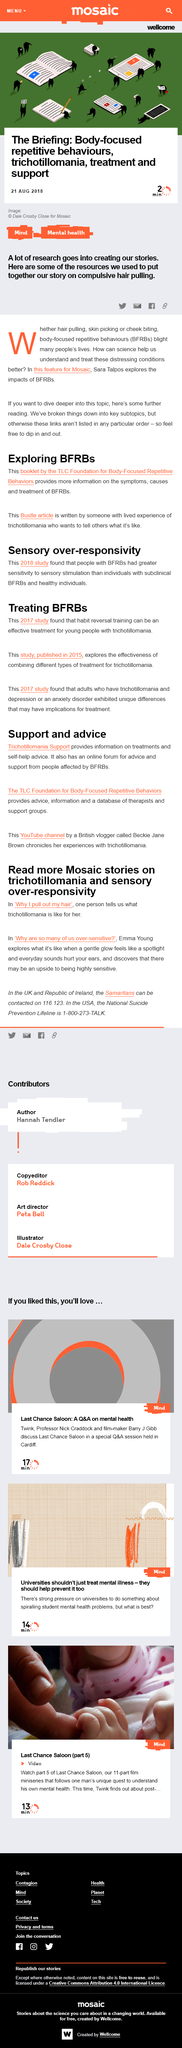Identify some key points in this picture. All studies involve trichotillomania, and trichotillomania is a condition characterized by repetitive hair-pulling from the scalp, eyebrows, or other areas of the body. This condition can lead to hair loss and scarring, and it is often associated with anxiety, depression, and other mental health conditions. While there are some effective treatments available for trichotillomania, it can be difficult to overcome without the right support and resources. Compulsive hair pulling, also known as trichotillomania, is a body-focused repetitive behavior characterized by the repetitive and compulsive urge to pull out one's hair, often resulting in hair loss. The date of the article is August 21, 2018. Reversal training, which was mentioned in a 2017 study, is a method of training in which learners are first taught about a negative outcome or mistake, followed by a later correction to produce a desired outcome. Beckie Jane Brown, a British vlogger, chronicles her experiences with trichotillomania in her videos. 